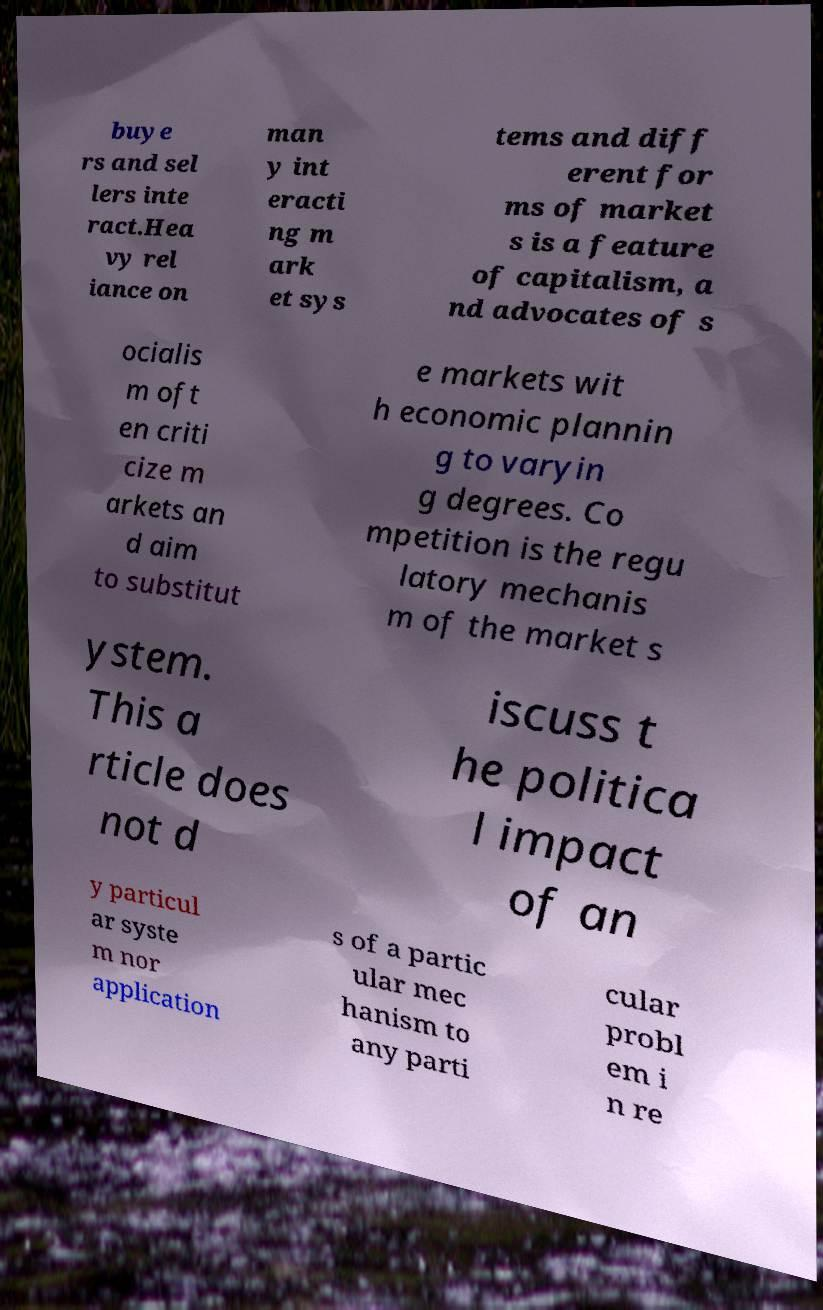What messages or text are displayed in this image? I need them in a readable, typed format. buye rs and sel lers inte ract.Hea vy rel iance on man y int eracti ng m ark et sys tems and diff erent for ms of market s is a feature of capitalism, a nd advocates of s ocialis m oft en criti cize m arkets an d aim to substitut e markets wit h economic plannin g to varyin g degrees. Co mpetition is the regu latory mechanis m of the market s ystem. This a rticle does not d iscuss t he politica l impact of an y particul ar syste m nor application s of a partic ular mec hanism to any parti cular probl em i n re 